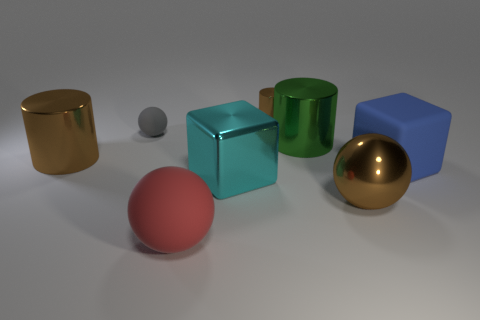Subtract 1 cylinders. How many cylinders are left? 2 Add 2 small brown metal objects. How many objects exist? 10 Subtract all cylinders. How many objects are left? 5 Subtract 1 red balls. How many objects are left? 7 Subtract all large cubes. Subtract all green rubber cylinders. How many objects are left? 6 Add 3 big objects. How many big objects are left? 9 Add 2 blue rubber things. How many blue rubber things exist? 3 